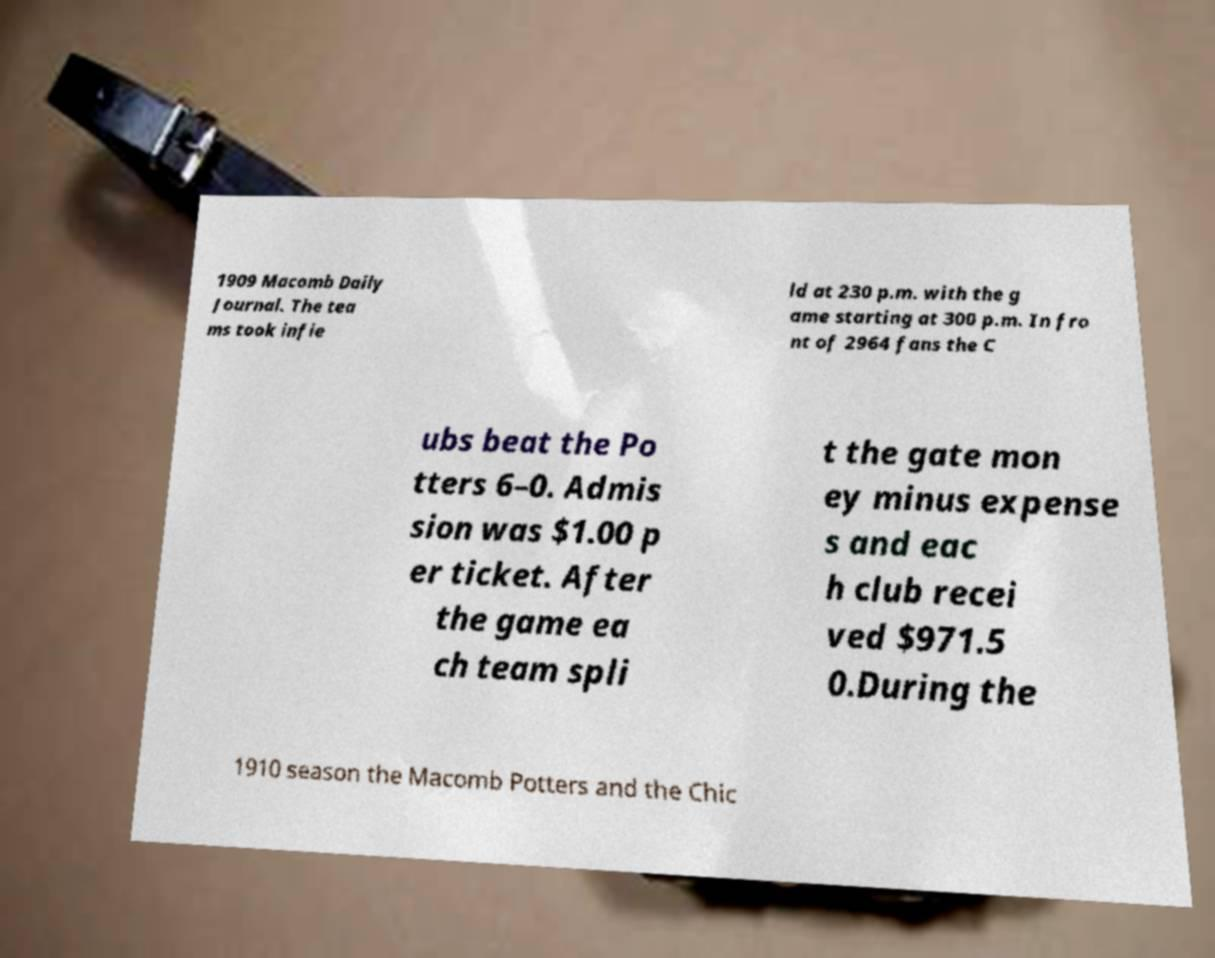What messages or text are displayed in this image? I need them in a readable, typed format. 1909 Macomb Daily Journal. The tea ms took infie ld at 230 p.m. with the g ame starting at 300 p.m. In fro nt of 2964 fans the C ubs beat the Po tters 6–0. Admis sion was $1.00 p er ticket. After the game ea ch team spli t the gate mon ey minus expense s and eac h club recei ved $971.5 0.During the 1910 season the Macomb Potters and the Chic 